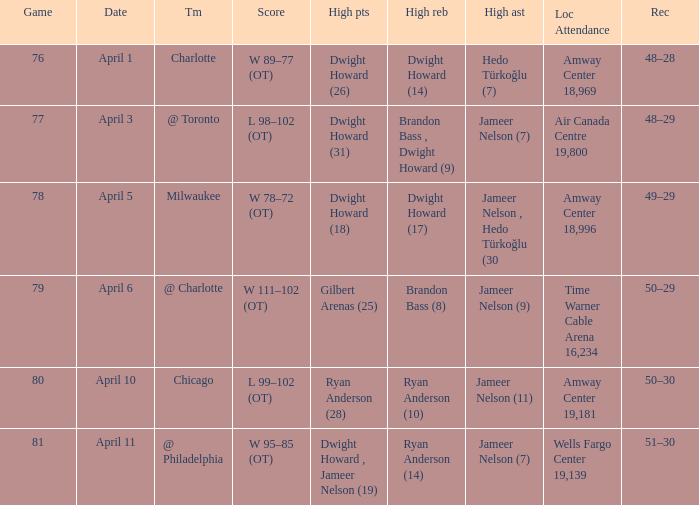Who had the most the most rebounds and how many did they have on April 1? Dwight Howard (14). 